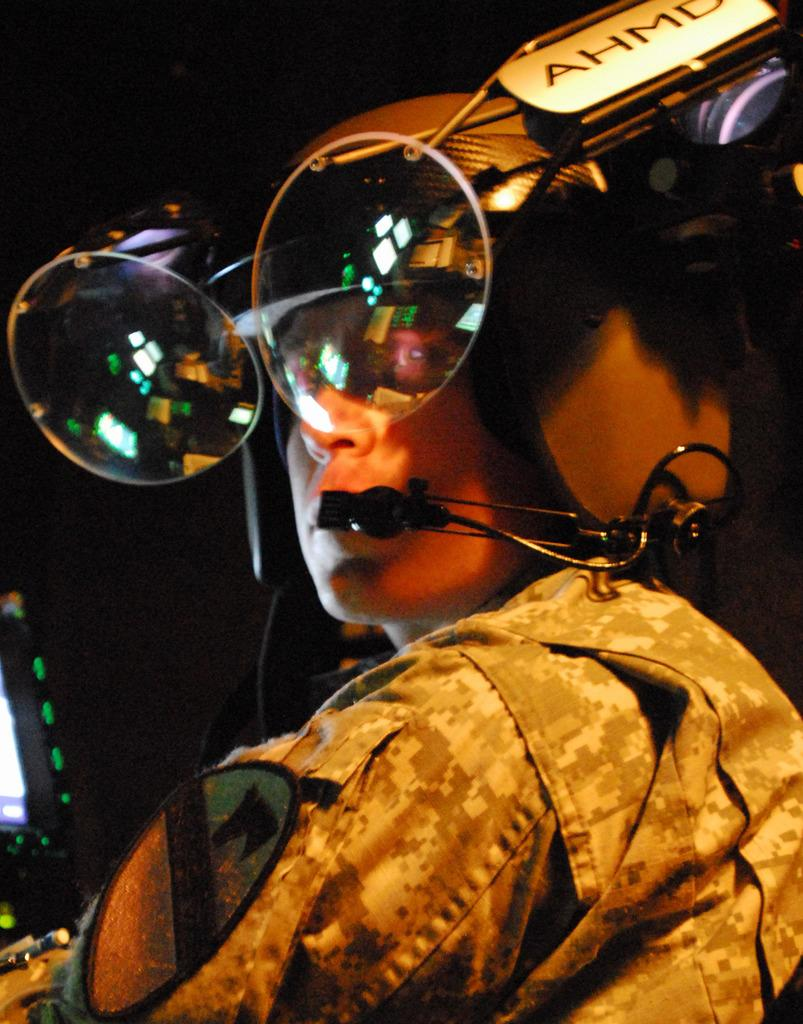What is the main subject of the image? There is a person in the image. What type of clothing is the person wearing? The person is wearing a uniform. What protective gear is the person wearing? The person is wearing a helmet and goggles attached to the helmet. What is the person holding or wearing for communication purposes? The person is wearing a microphone. What can be seen on the left side of the image? There is a screen on the left side of the image. What is the color of the background in the image? The background of the image is black. How many geese are visible in the image? There are no geese present in the image. What type of brush is the person using in the image? There is no brush visible in the image. 